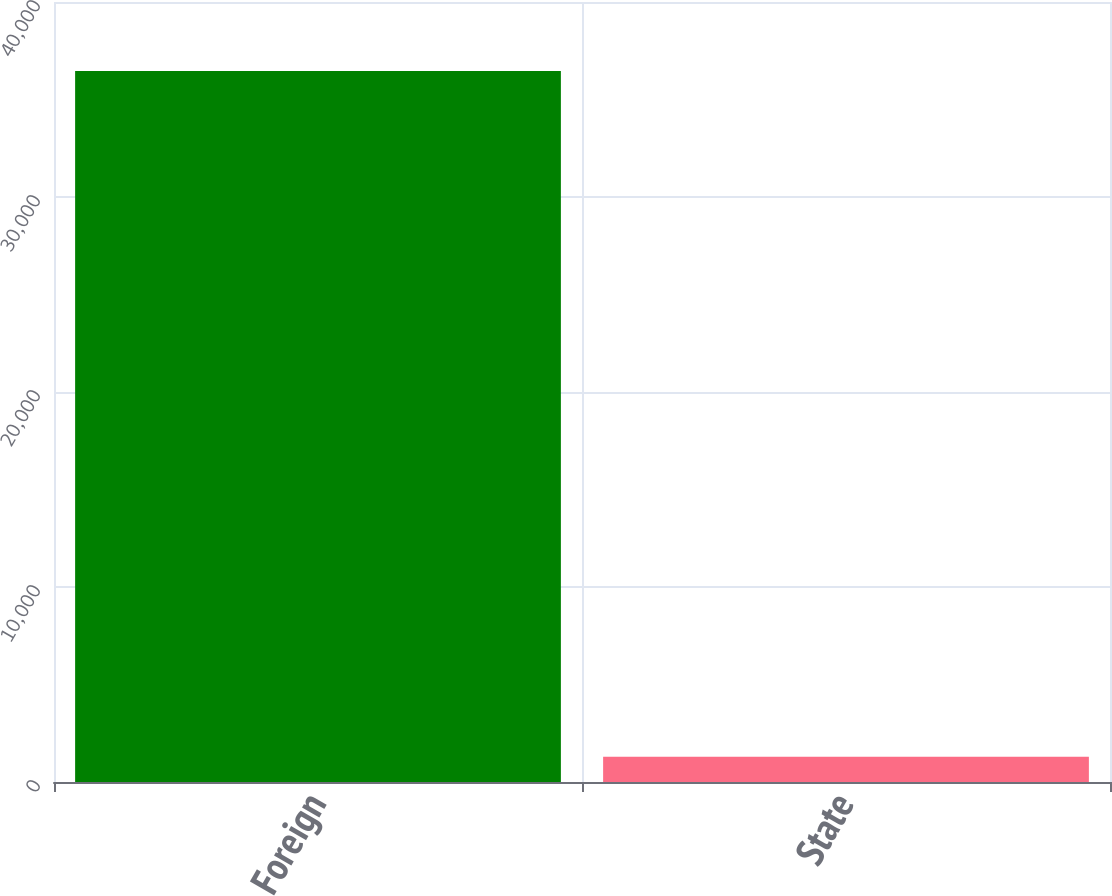<chart> <loc_0><loc_0><loc_500><loc_500><bar_chart><fcel>Foreign<fcel>State<nl><fcel>36462<fcel>1295<nl></chart> 